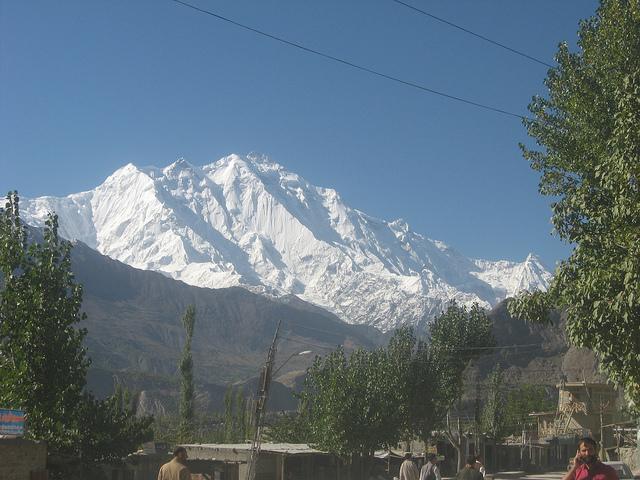Where are the biggest trees positioned in this picture?
Be succinct. Right. Is this a high mountain?
Keep it brief. Yes. Are most of the people entering or leaving?
Short answer required. Entering. How many trees are there?
Be succinct. 5. What country is this in?
Quick response, please. Switzerland. How many benches are in the photo?
Short answer required. 0. What activity is the man in the red shirt engaging in?
Answer briefly. Talking on phone. What kind of trees are these?
Keep it brief. Oak. 